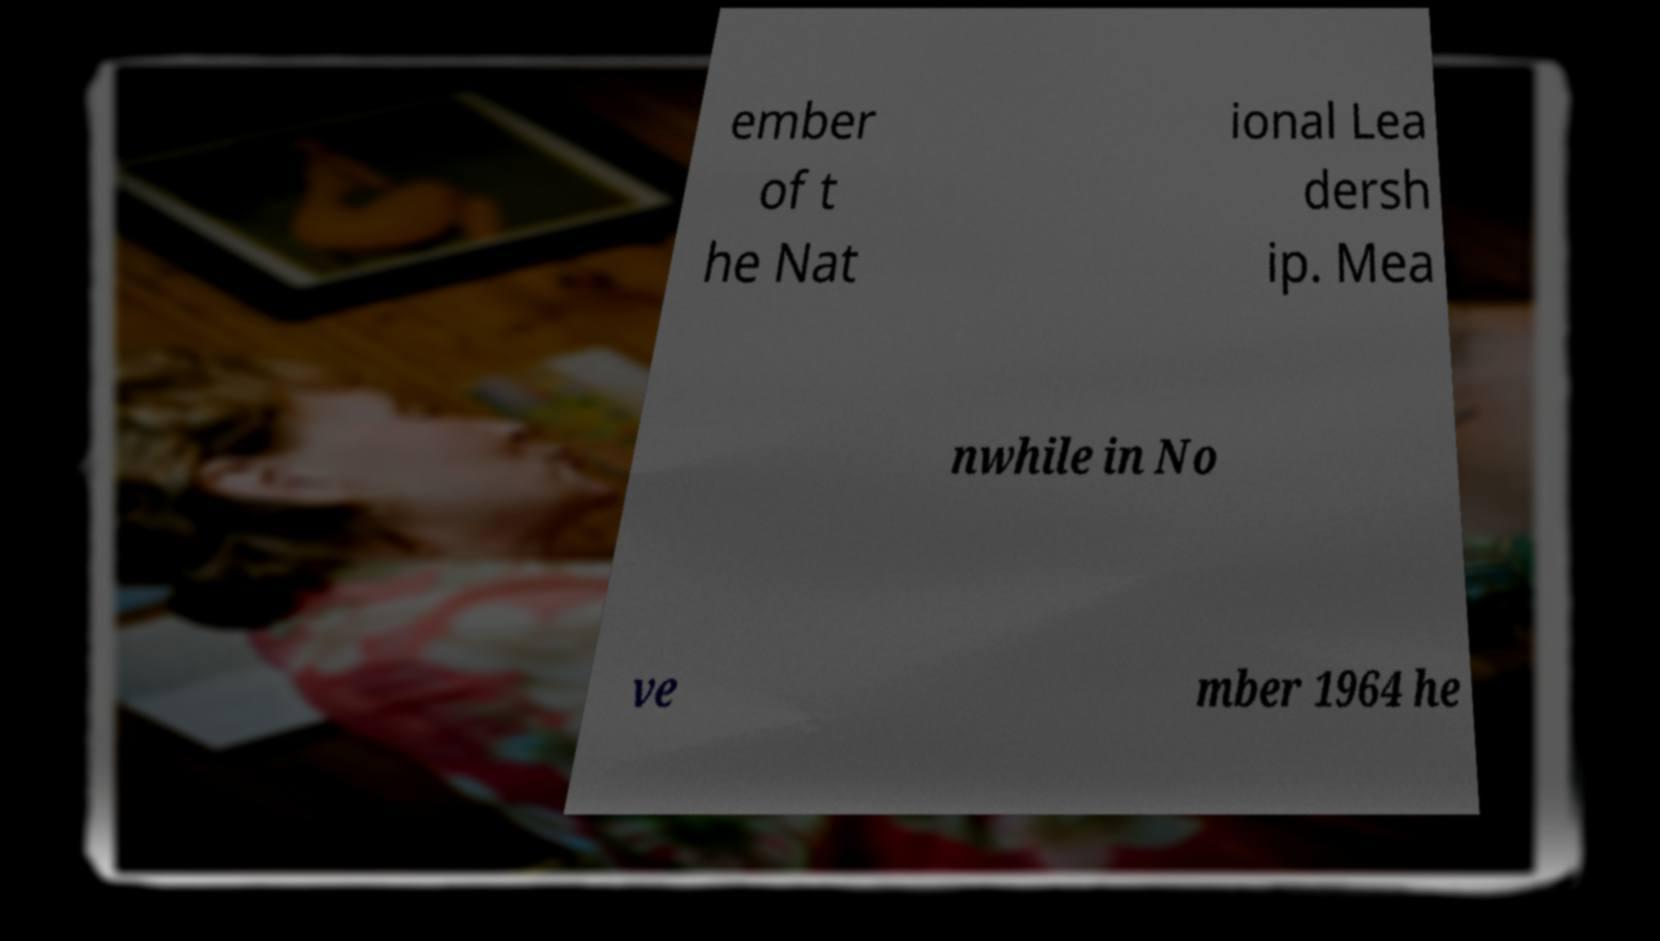For documentation purposes, I need the text within this image transcribed. Could you provide that? ember of t he Nat ional Lea dersh ip. Mea nwhile in No ve mber 1964 he 